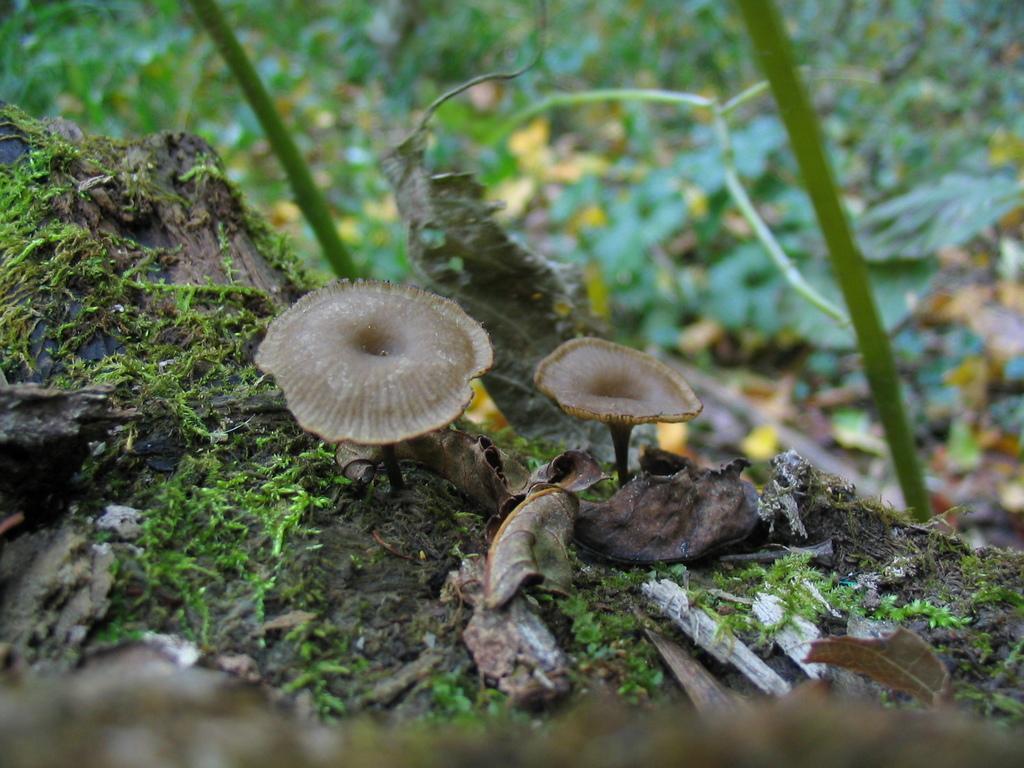Could you give a brief overview of what you see in this image? In this image I can see two brown color mushrooms, the grass, dry leaves and background is blurred. 